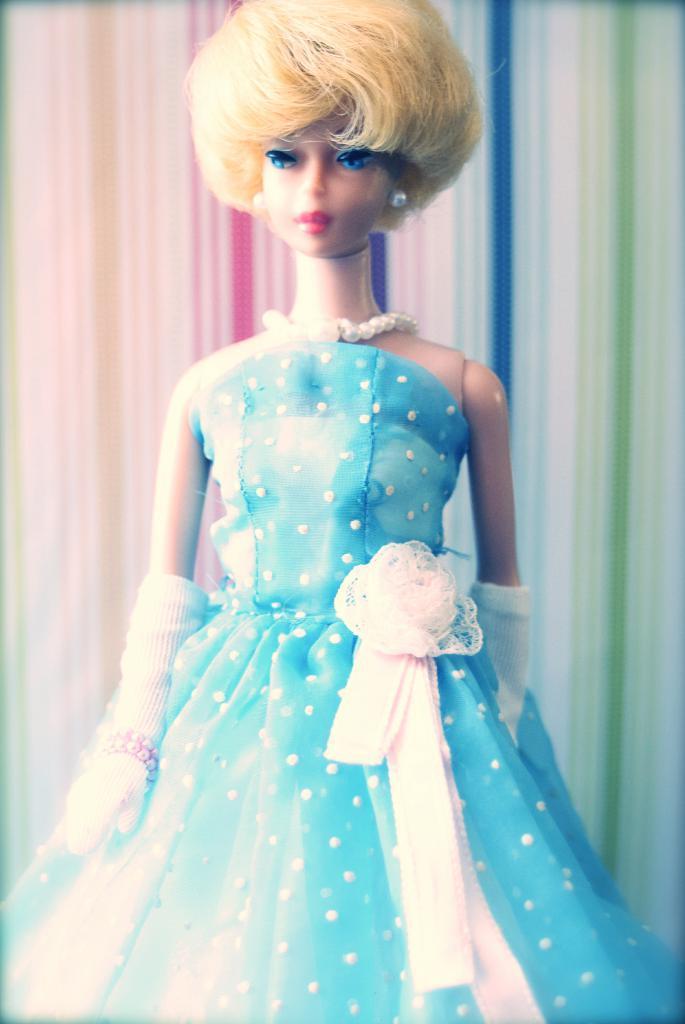Can you describe this image briefly? This picture contains a barbie doll in blue dress. In the background, it is colorful. 